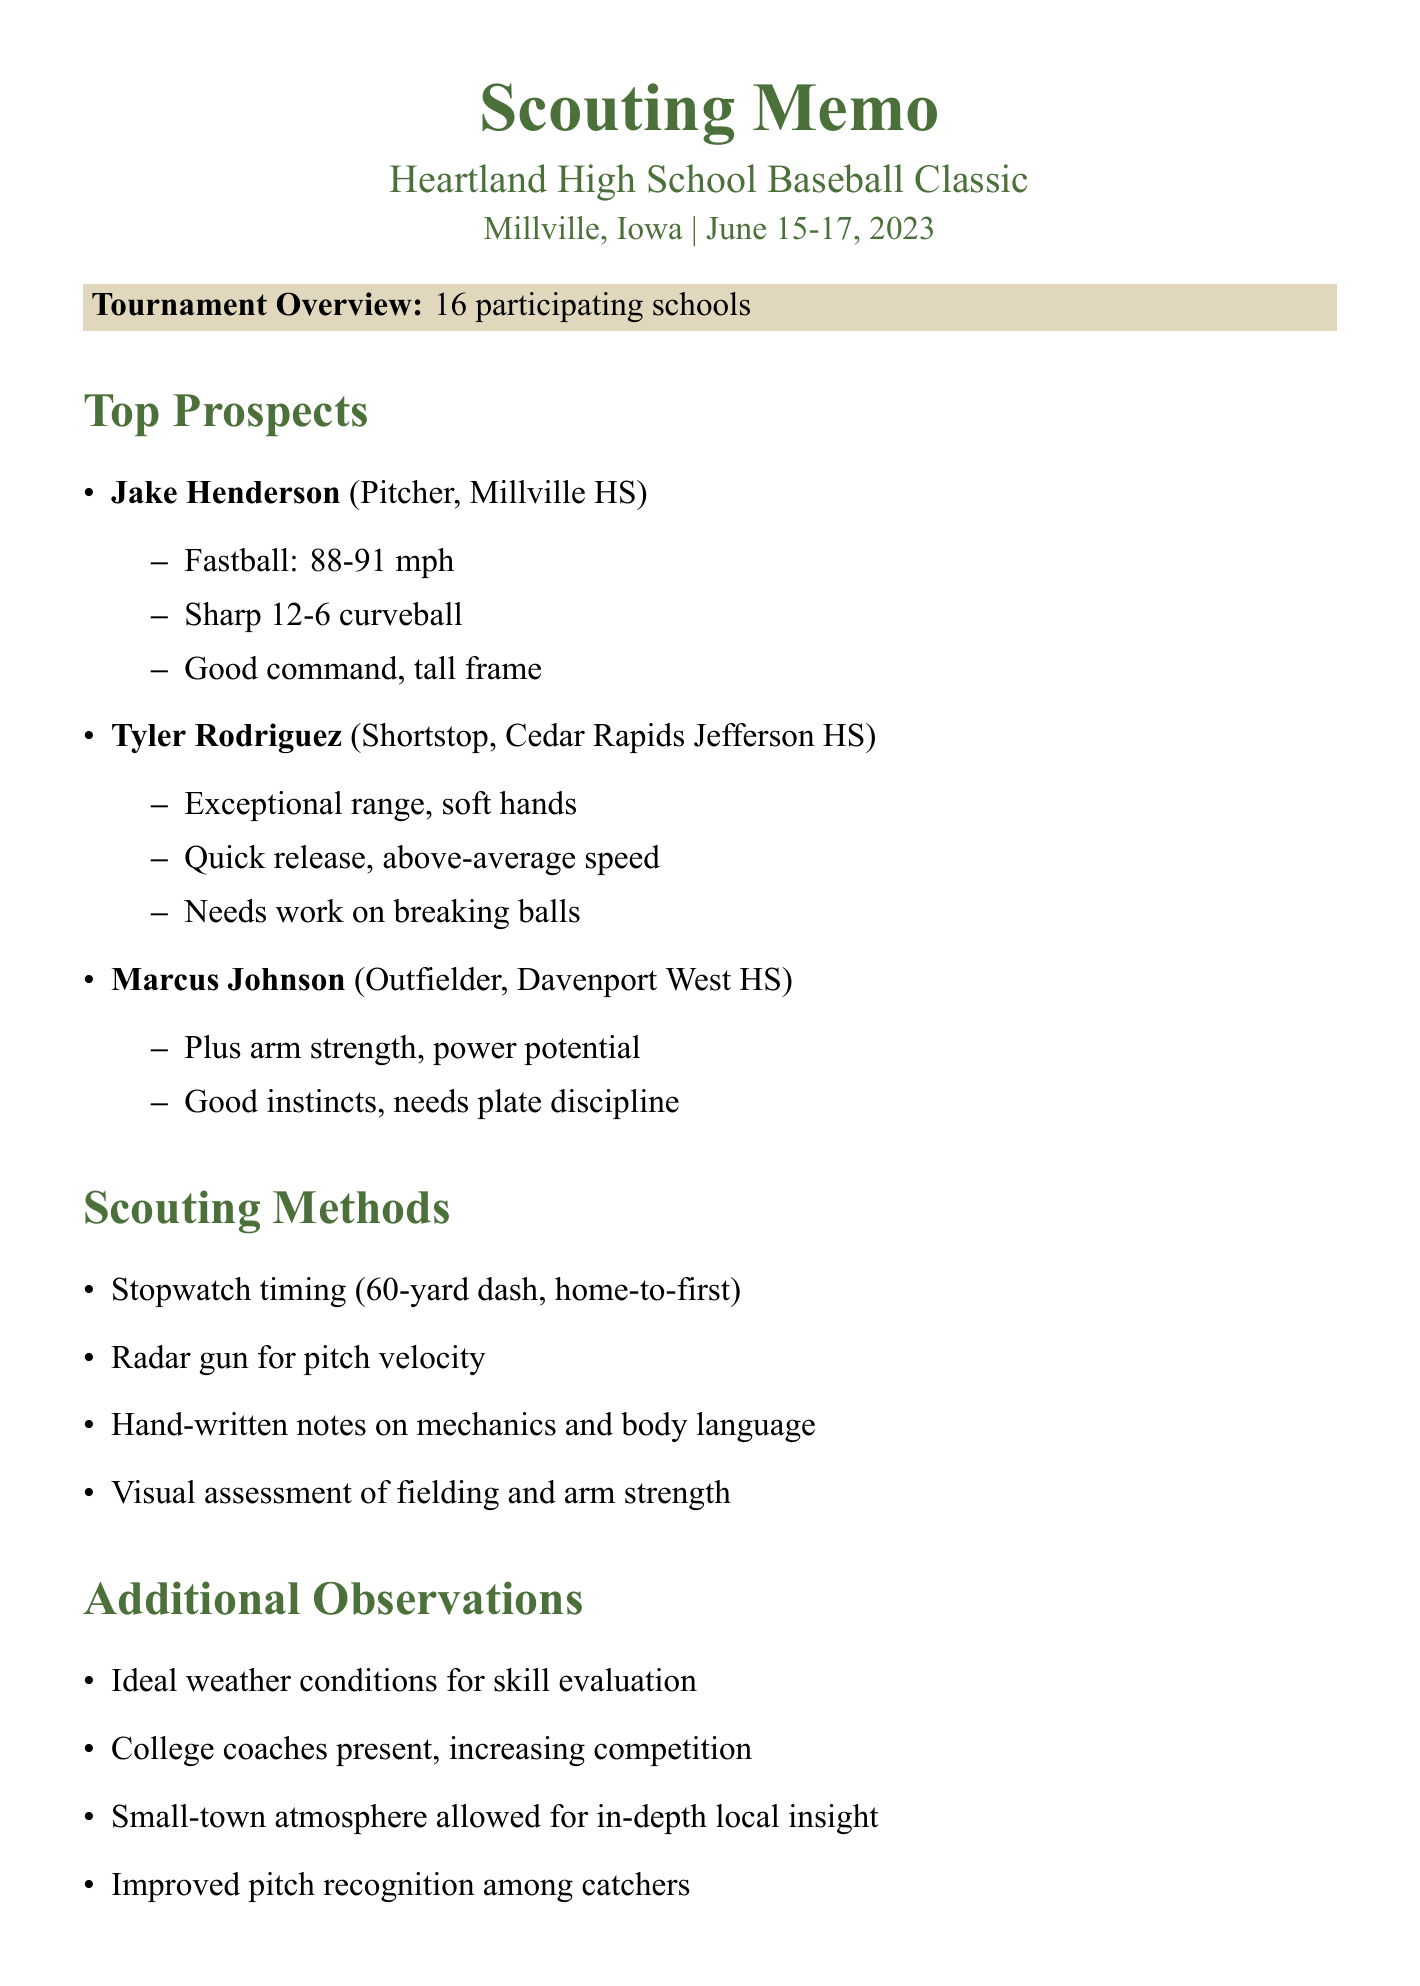What is the name of the tournament? The name of the tournament is mentioned as "Heartland High School Baseball Classic."
Answer: Heartland High School Baseball Classic How many schools participated in the tournament? The document states that there were 16 participating schools in the tournament.
Answer: 16 Who is the top prospect from Millville High School? The document lists Jake Henderson as the top prospect from Millville High School.
Answer: Jake Henderson What is Tyler Rodriguez's primary position? Tyler Rodriguez's position is indicated as Shortstop in the observations.
Answer: Shortstop What was the weather condition during the tournament? The document notes that the weather conditions were ideal for evaluating true skills.
Answer: Ideal What skill does Marcus Johnson need to work on? The document states that Marcus Johnson needs to work on plate discipline.
Answer: Plate discipline Which equipment was used for measuring pitch velocity? The document mentions that a Jugs radar gun was used for measuring pitching velocity.
Answer: Jugs radar gun What follow-up action is planned for Jake Henderson? The document states that a return visit is scheduled to watch Jake Henderson pitch against tougher competition.
Answer: Schedule return visit How was the assessment of player mechanics recorded? The document mentions that hand-written notes were made on player mechanics and body language.
Answer: Hand-written notes 